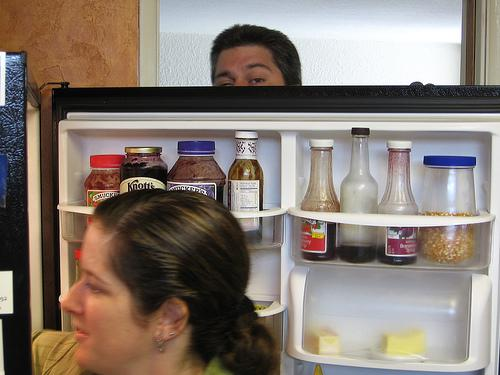Question: where was the photo taken?
Choices:
A. Patio.
B. Balcony.
C. Living room.
D. Kitchen.
Answer with the letter. Answer: D Question: who is in the fridge?
Choices:
A. The woman.
B. The man.
C. The boy.
D. The girl.
Answer with the letter. Answer: A 